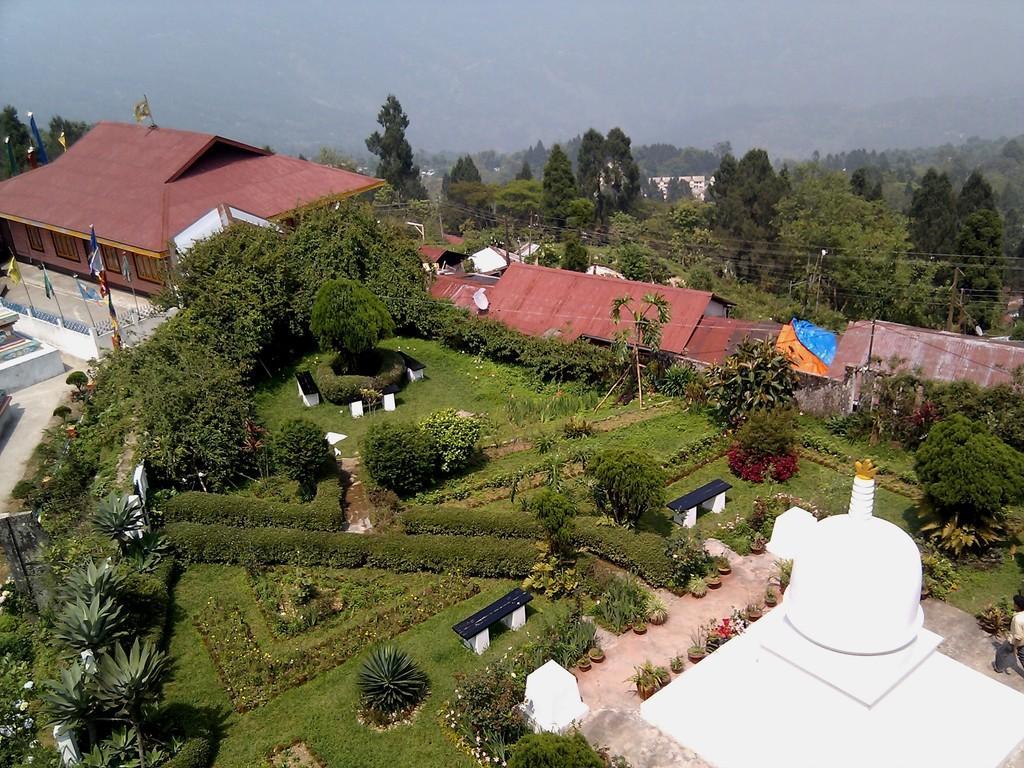Please provide a concise description of this image. There are grass lawns, trees and plants. On the grass lawn there are benches. Near to that there are buildings. On the left side there is a wall. Near to the wall there are flags with poles. On the right side there is a white color structure. In the background there are trees and it is looking foggy. 